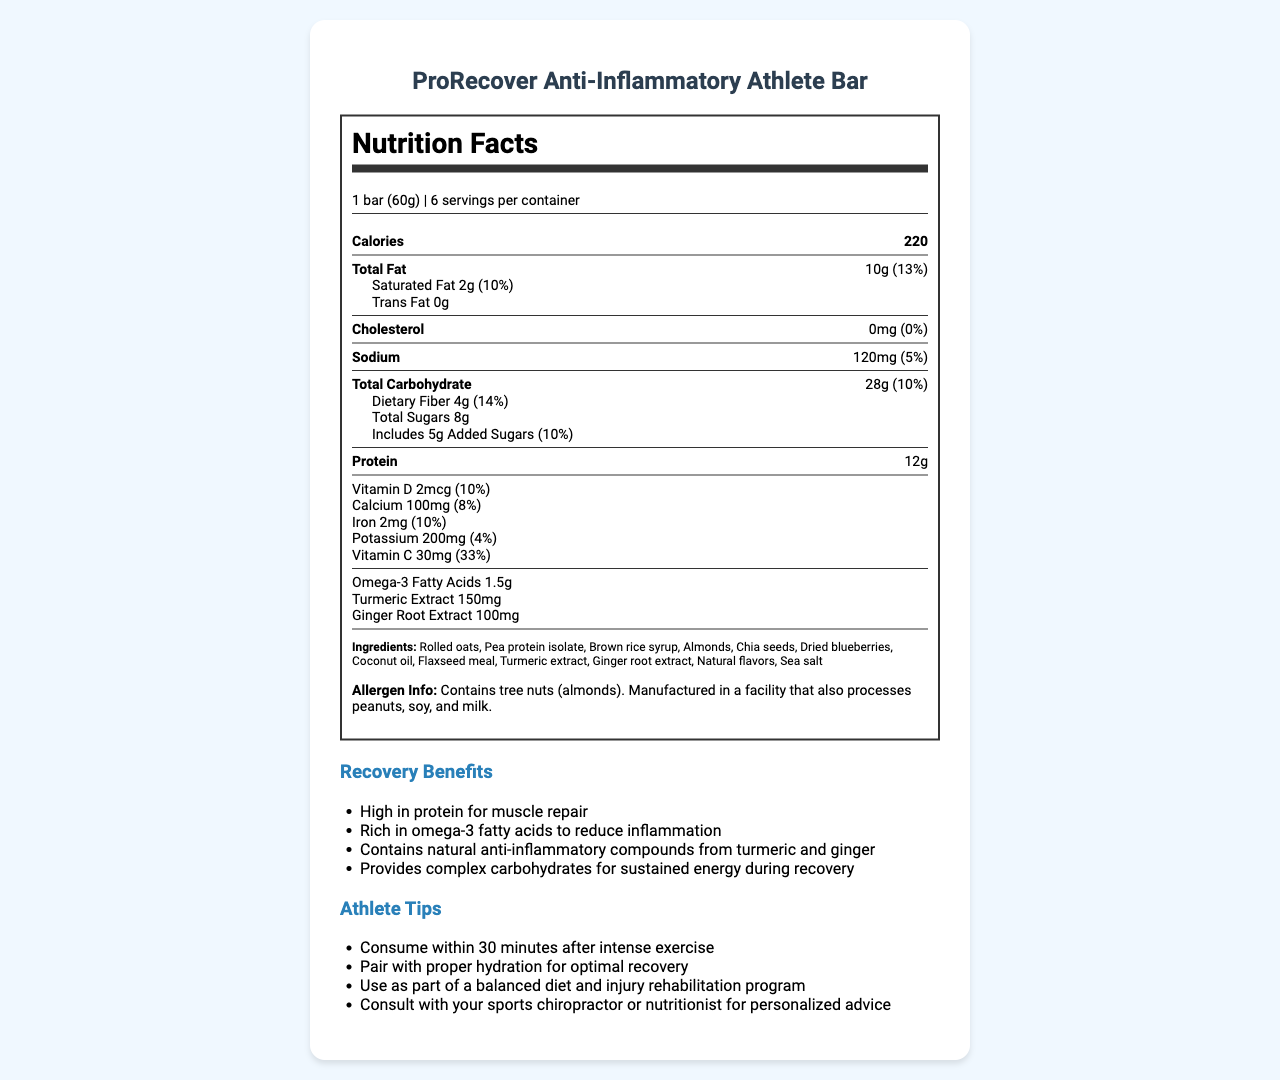what is the serving size of the ProRecover Anti-Inflammatory Athlete Bar? The serving size is listed at the top below the product name as "1 bar (60g)".
Answer: 1 bar (60g) how many calories does one serving of this snack bar contain? The nutrition information lists "Calories" with a value of 220.
Answer: 220 calories how much total fat is in one serving of the bar? The total fat content is stated as "Total Fat: 10g."
Answer: 10g what are the two listed anti-inflammatory compounds in the recovery bar? The document directly lists "Turmeric extract" and "Ginger root extract" under the nutrition information.
Answer: Turmeric extract and Ginger root extract what percentage of the daily value of fiber does one bar provide? The "Dietary Fiber" section of the nutrition label states it provides "14%."
Answer: 14% how many grams of proteins are in one serving? The nutrition label states "Protein: 12g."
Answer: 12g which ingredient in the bar is a common allergen? A. Peanuts B. Almonds C. Soy D. Milk The allergen information section mentions that the product contains tree nuts (almonds).
Answer: B. Almonds what minerals does the bar provide, and how can these benefit recovering athletes? Select all that apply: i. Calcium ii. Iron iii. Potassium iv. Sodium The minerals provided are listed in the nutrition label: Calcium (100mg), Iron (2mg), and Potassium (200mg).
Answer: i, ii, iii does the product contain any cholesterol? The nutrition label indicates "Cholesterol: 0mg (0%)."
Answer: No are there any added sugars in the bar? The label shows "Includes 5g Added Sugars (10%)."
Answer: Yes does the product contain trans fat? The nutrition label states "Trans Fat: 0g."
Answer: No summarize the main benefits and usage tips provided for the ProRecover Anti-Inflammatory Athlete Bar. The summary covers the recovery benefits and athlete tips sections, which outline the advantages of the bar and practical advice for its use.
Answer: The ProRecover Anti-Inflammatory Athlete Bar offers several benefits for athletes recovering from minor injuries, including high protein for muscle repair, omega-3 fatty acids to reduce inflammation, and natural anti-inflammatory compounds from turmeric and ginger. The bar provides complex carbohydrates for sustained energy during recovery. Usage tips for optimal recovery include consuming the bar within 30 minutes after intense exercise, pairing it with proper hydration, and using it as part of a balanced diet and injury rehabilitation program. Consultation with a sports chiropractor or nutritionist is recommended for personalized advice. what flavor is the ProRecover Anti-Inflammatory Athlete Bar? The document does not provide details about the flavor, only the ingredients and the nutritional content.
Answer: I don't know 